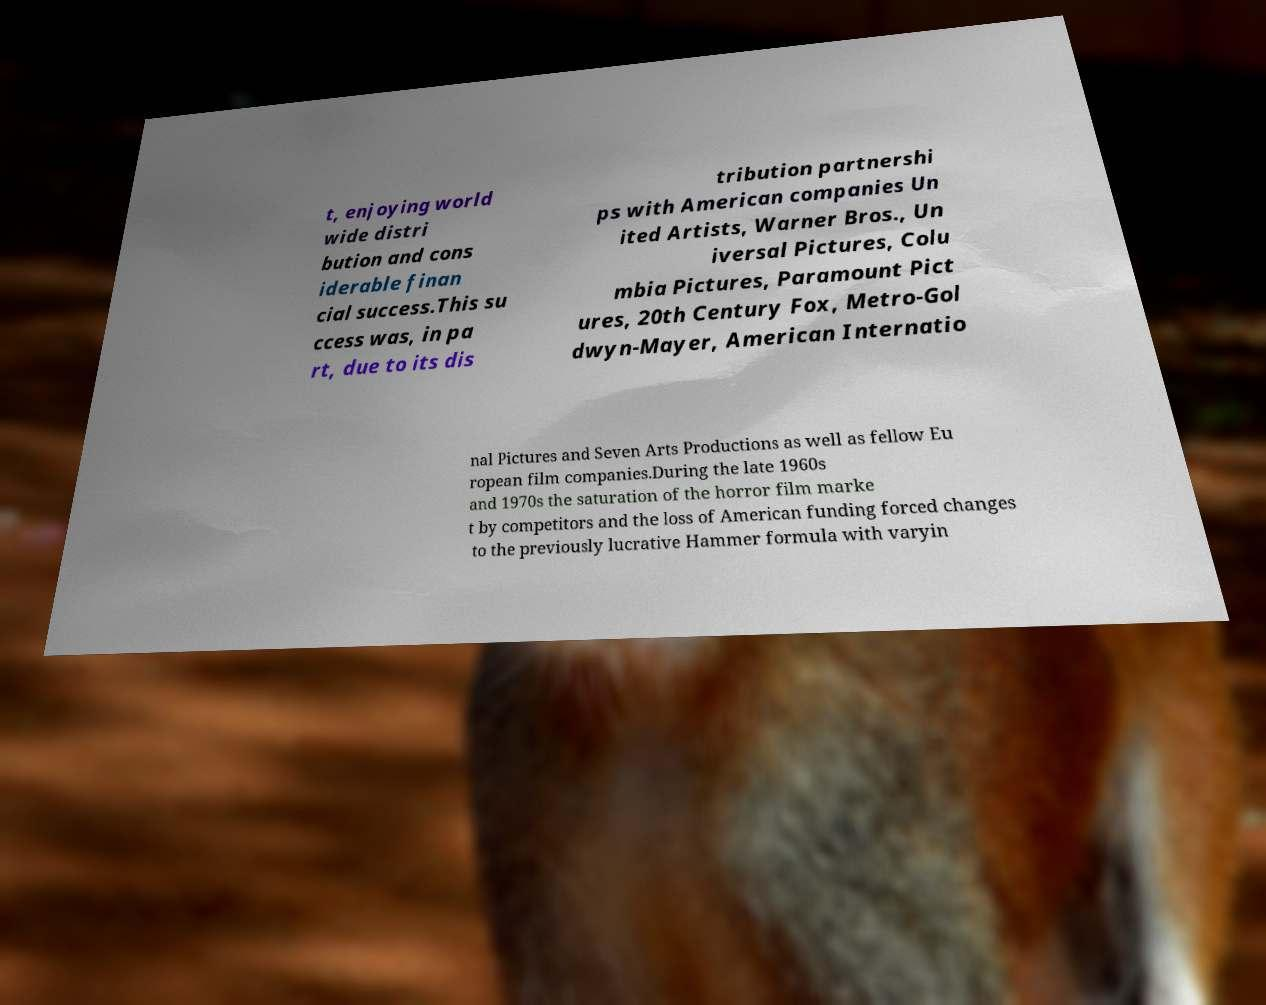For documentation purposes, I need the text within this image transcribed. Could you provide that? t, enjoying world wide distri bution and cons iderable finan cial success.This su ccess was, in pa rt, due to its dis tribution partnershi ps with American companies Un ited Artists, Warner Bros., Un iversal Pictures, Colu mbia Pictures, Paramount Pict ures, 20th Century Fox, Metro-Gol dwyn-Mayer, American Internatio nal Pictures and Seven Arts Productions as well as fellow Eu ropean film companies.During the late 1960s and 1970s the saturation of the horror film marke t by competitors and the loss of American funding forced changes to the previously lucrative Hammer formula with varyin 